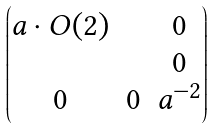<formula> <loc_0><loc_0><loc_500><loc_500>\begin{pmatrix} a \cdot O ( 2 ) & & 0 \\ & & 0 \\ 0 & 0 & a ^ { - 2 } \end{pmatrix}</formula> 